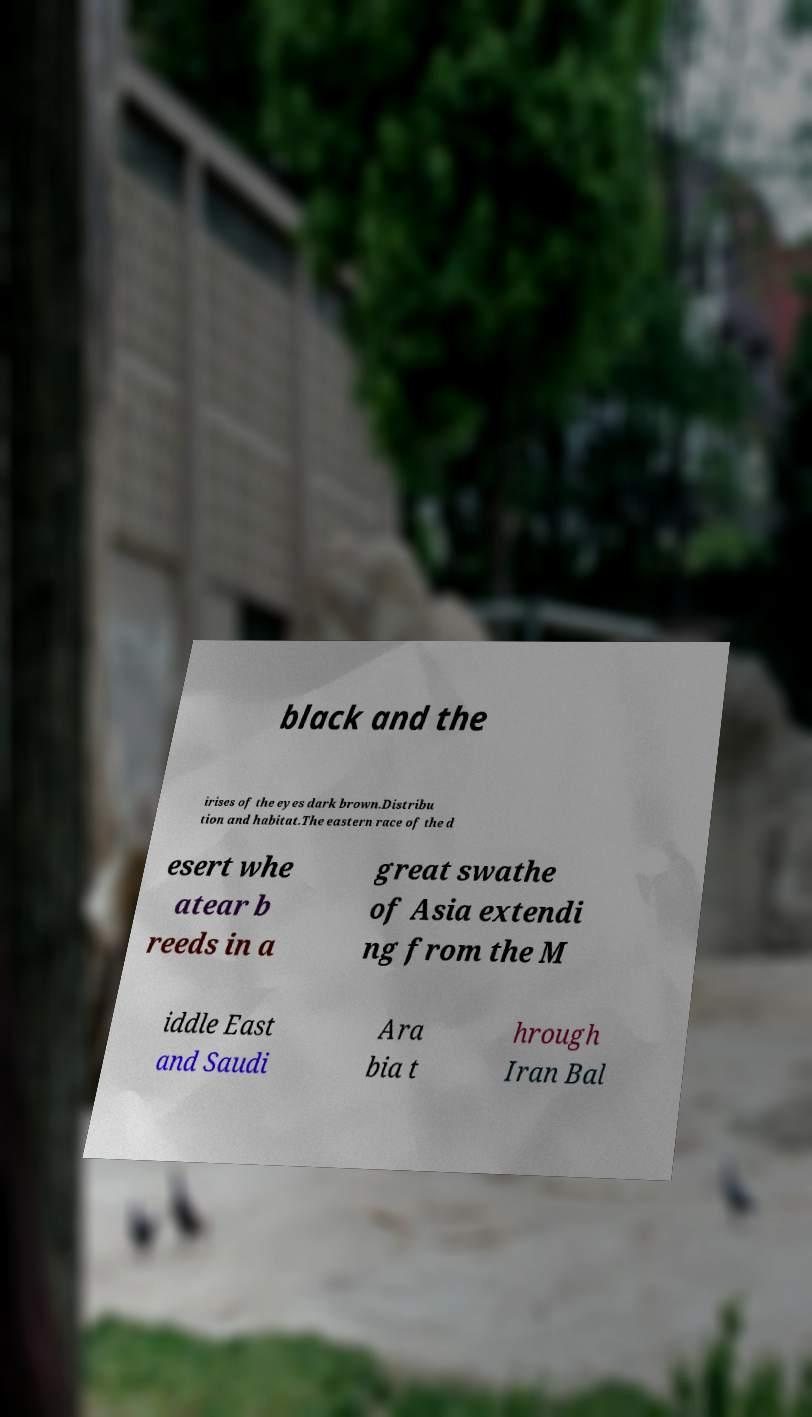Can you accurately transcribe the text from the provided image for me? black and the irises of the eyes dark brown.Distribu tion and habitat.The eastern race of the d esert whe atear b reeds in a great swathe of Asia extendi ng from the M iddle East and Saudi Ara bia t hrough Iran Bal 